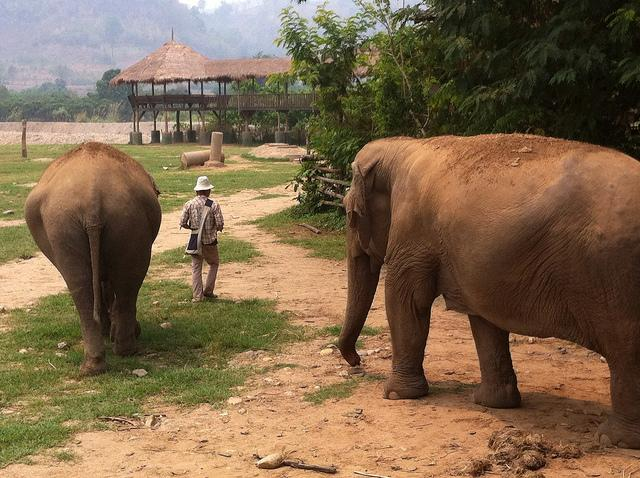What is between the elephants? man 